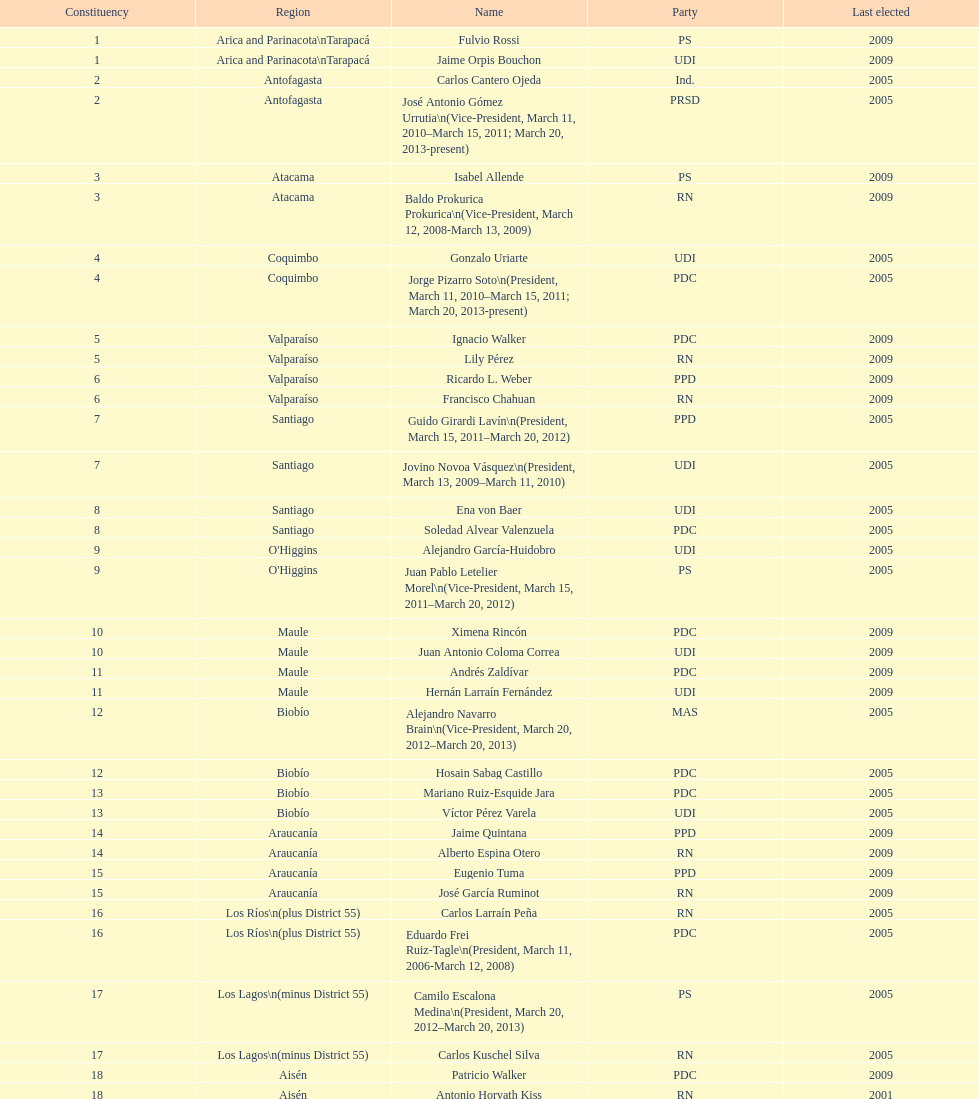What is the total number of constituencies listed in the table? 19. 